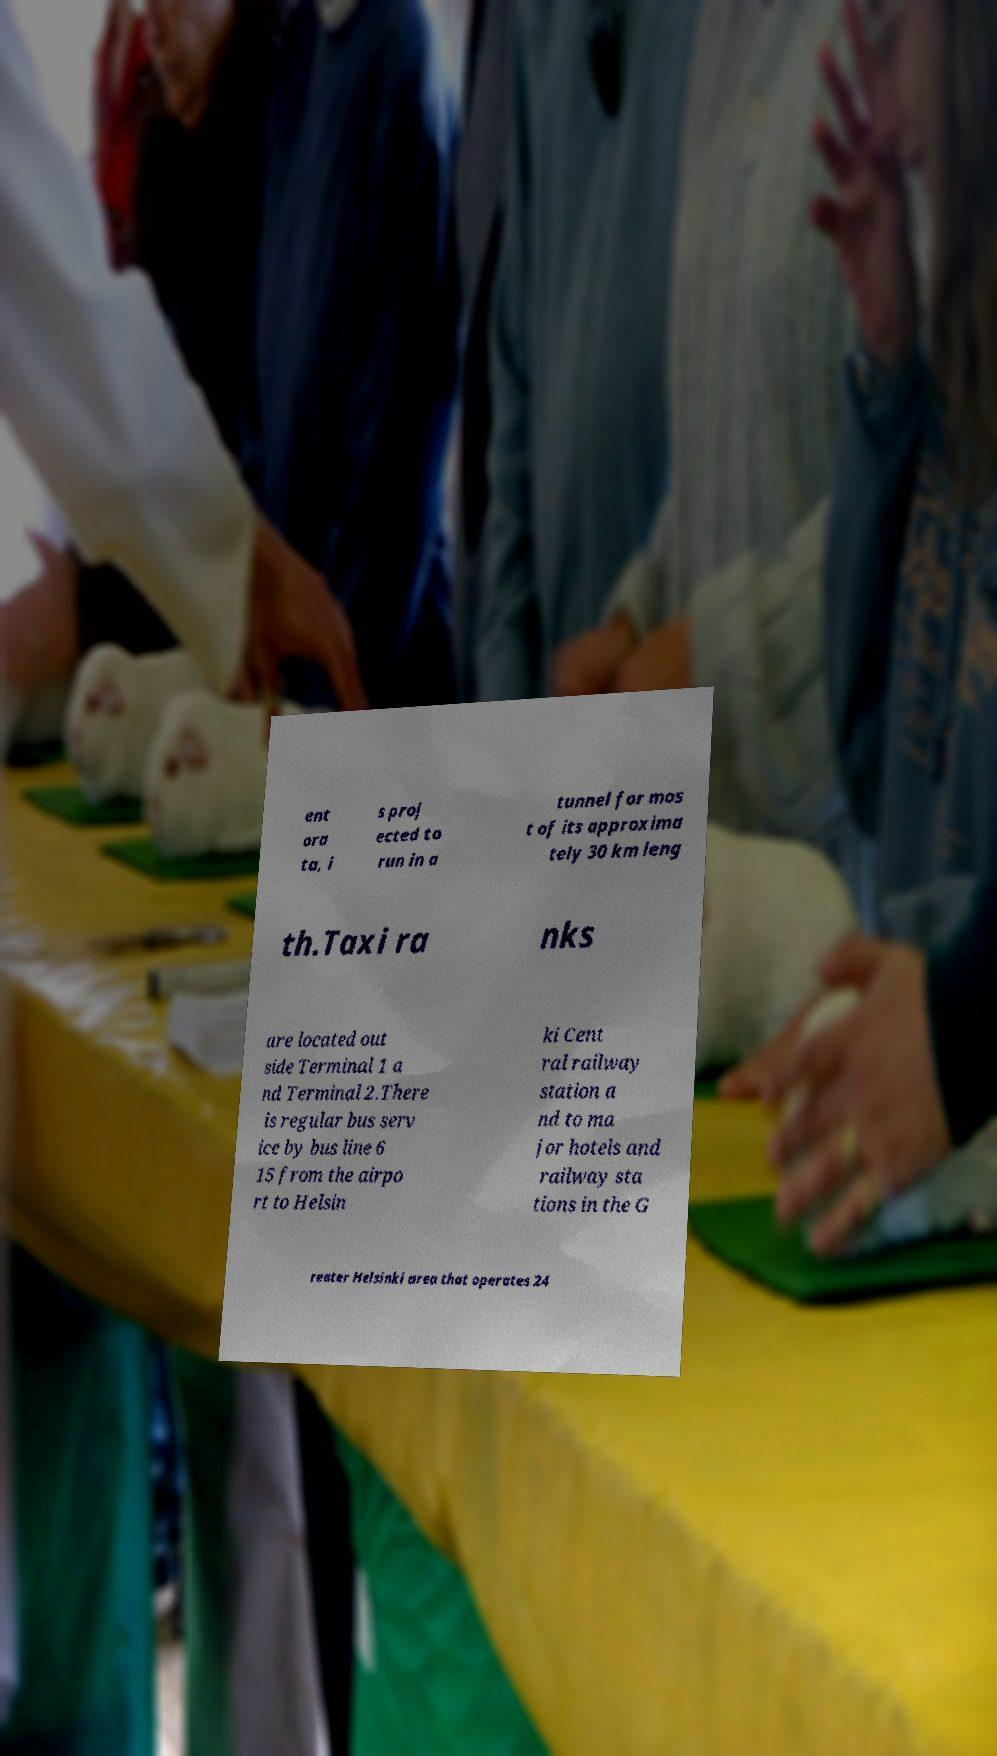Can you accurately transcribe the text from the provided image for me? ent ora ta, i s proj ected to run in a tunnel for mos t of its approxima tely 30 km leng th.Taxi ra nks are located out side Terminal 1 a nd Terminal 2.There is regular bus serv ice by bus line 6 15 from the airpo rt to Helsin ki Cent ral railway station a nd to ma jor hotels and railway sta tions in the G reater Helsinki area that operates 24 